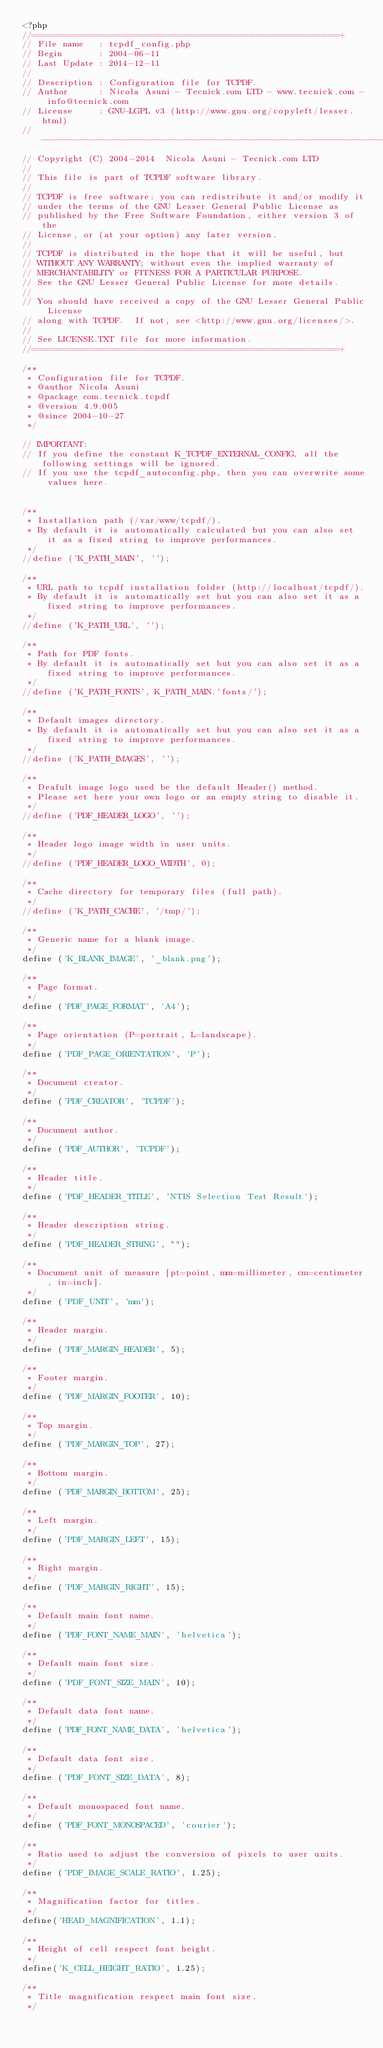Convert code to text. <code><loc_0><loc_0><loc_500><loc_500><_PHP_><?php
//============================================================+
// File name   : tcpdf_config.php
// Begin       : 2004-06-11
// Last Update : 2014-12-11
//
// Description : Configuration file for TCPDF.
// Author      : Nicola Asuni - Tecnick.com LTD - www.tecnick.com - info@tecnick.com
// License     : GNU-LGPL v3 (http://www.gnu.org/copyleft/lesser.html)
// -------------------------------------------------------------------
// Copyright (C) 2004-2014  Nicola Asuni - Tecnick.com LTD
//
// This file is part of TCPDF software library.
//
// TCPDF is free software: you can redistribute it and/or modify it
// under the terms of the GNU Lesser General Public License as
// published by the Free Software Foundation, either version 3 of the
// License, or (at your option) any later version.
//
// TCPDF is distributed in the hope that it will be useful, but
// WITHOUT ANY WARRANTY; without even the implied warranty of
// MERCHANTABILITY or FITNESS FOR A PARTICULAR PURPOSE.
// See the GNU Lesser General Public License for more details.
//
// You should have received a copy of the GNU Lesser General Public License
// along with TCPDF.  If not, see <http://www.gnu.org/licenses/>.
//
// See LICENSE.TXT file for more information.
//============================================================+

/**
 * Configuration file for TCPDF.
 * @author Nicola Asuni
 * @package com.tecnick.tcpdf
 * @version 4.9.005
 * @since 2004-10-27
 */

// IMPORTANT:
// If you define the constant K_TCPDF_EXTERNAL_CONFIG, all the following settings will be ignored.
// If you use the tcpdf_autoconfig.php, then you can overwrite some values here.


/**
 * Installation path (/var/www/tcpdf/).
 * By default it is automatically calculated but you can also set it as a fixed string to improve performances.
 */
//define ('K_PATH_MAIN', '');

/**
 * URL path to tcpdf installation folder (http://localhost/tcpdf/).
 * By default it is automatically set but you can also set it as a fixed string to improve performances.
 */
//define ('K_PATH_URL', '');

/**
 * Path for PDF fonts.
 * By default it is automatically set but you can also set it as a fixed string to improve performances.
 */
//define ('K_PATH_FONTS', K_PATH_MAIN.'fonts/');

/**
 * Default images directory.
 * By default it is automatically set but you can also set it as a fixed string to improve performances.
 */
//define ('K_PATH_IMAGES', '');

/**
 * Deafult image logo used be the default Header() method.
 * Please set here your own logo or an empty string to disable it.
 */
//define ('PDF_HEADER_LOGO', '');

/**
 * Header logo image width in user units.
 */
//define ('PDF_HEADER_LOGO_WIDTH', 0);

/**
 * Cache directory for temporary files (full path).
 */
//define ('K_PATH_CACHE', '/tmp/');

/**
 * Generic name for a blank image.
 */
define ('K_BLANK_IMAGE', '_blank.png');

/**
 * Page format.
 */
define ('PDF_PAGE_FORMAT', 'A4');

/**
 * Page orientation (P=portrait, L=landscape).
 */
define ('PDF_PAGE_ORIENTATION', 'P');

/**
 * Document creator.
 */
define ('PDF_CREATOR', 'TCPDF');

/**
 * Document author.
 */
define ('PDF_AUTHOR', 'TCPDF');

/**
 * Header title.
 */
define ('PDF_HEADER_TITLE', 'NTIS Selection Test Result');

/**
 * Header description string.
 */
define ('PDF_HEADER_STRING', "");

/**
 * Document unit of measure [pt=point, mm=millimeter, cm=centimeter, in=inch].
 */
define ('PDF_UNIT', 'mm');

/**
 * Header margin.
 */
define ('PDF_MARGIN_HEADER', 5);

/**
 * Footer margin.
 */
define ('PDF_MARGIN_FOOTER', 10);

/**
 * Top margin.
 */
define ('PDF_MARGIN_TOP', 27);

/**
 * Bottom margin.
 */
define ('PDF_MARGIN_BOTTOM', 25);

/**
 * Left margin.
 */
define ('PDF_MARGIN_LEFT', 15);

/**
 * Right margin.
 */
define ('PDF_MARGIN_RIGHT', 15);

/**
 * Default main font name.
 */
define ('PDF_FONT_NAME_MAIN', 'helvetica');

/**
 * Default main font size.
 */
define ('PDF_FONT_SIZE_MAIN', 10);

/**
 * Default data font name.
 */
define ('PDF_FONT_NAME_DATA', 'helvetica');

/**
 * Default data font size.
 */
define ('PDF_FONT_SIZE_DATA', 8);

/**
 * Default monospaced font name.
 */
define ('PDF_FONT_MONOSPACED', 'courier');

/**
 * Ratio used to adjust the conversion of pixels to user units.
 */
define ('PDF_IMAGE_SCALE_RATIO', 1.25);

/**
 * Magnification factor for titles.
 */
define('HEAD_MAGNIFICATION', 1.1);

/**
 * Height of cell respect font height.
 */
define('K_CELL_HEIGHT_RATIO', 1.25);

/**
 * Title magnification respect main font size.
 */</code> 